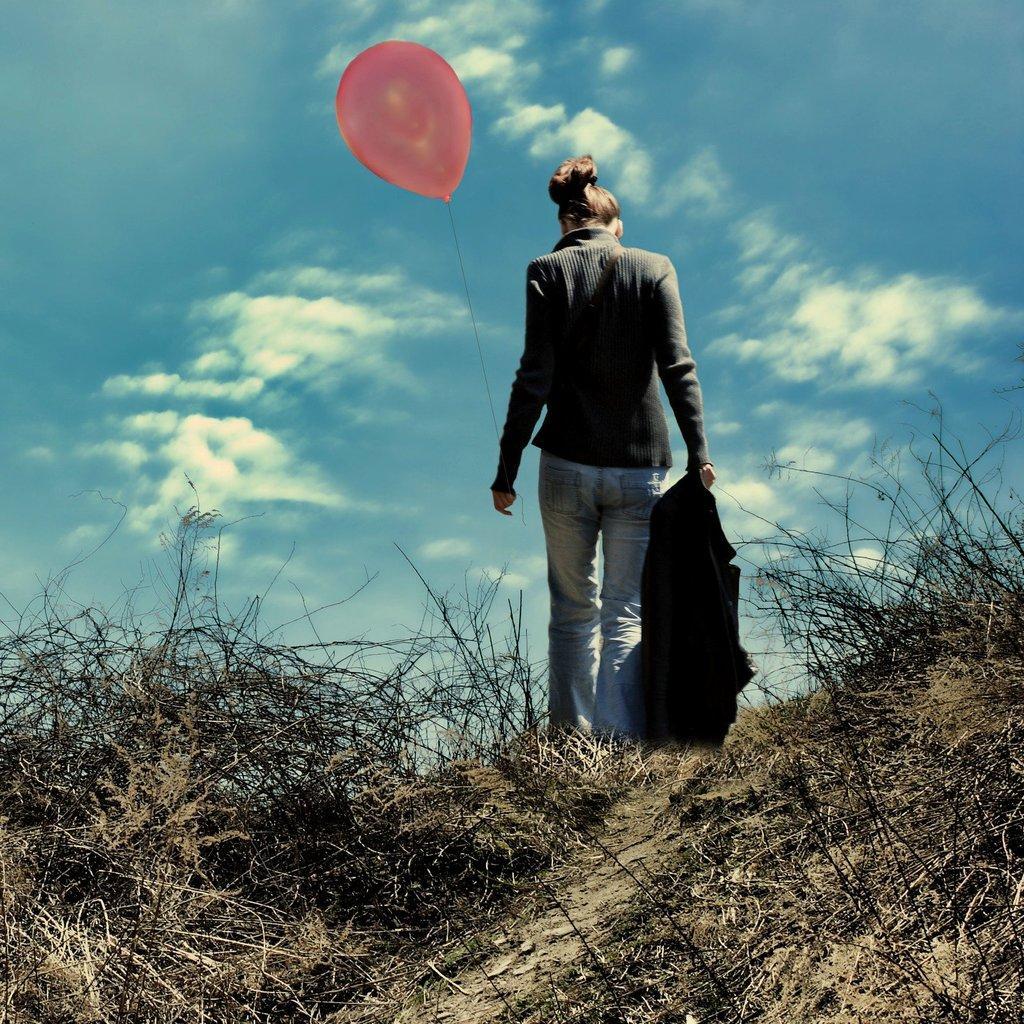In one or two sentences, can you explain what this image depicts? In the front portion of the picture we can see a dried grass area with dried twigs. There ia a woman standing wearing a light blue jeans and ash colour long sleeve length shirt. This woman is holding a black jacket in her hand. On the other hand she is holding a balloon which is peach in colour. on the top of the picture we can see a clear blue sky with clouds. The hair colour of the woman is brownish. 